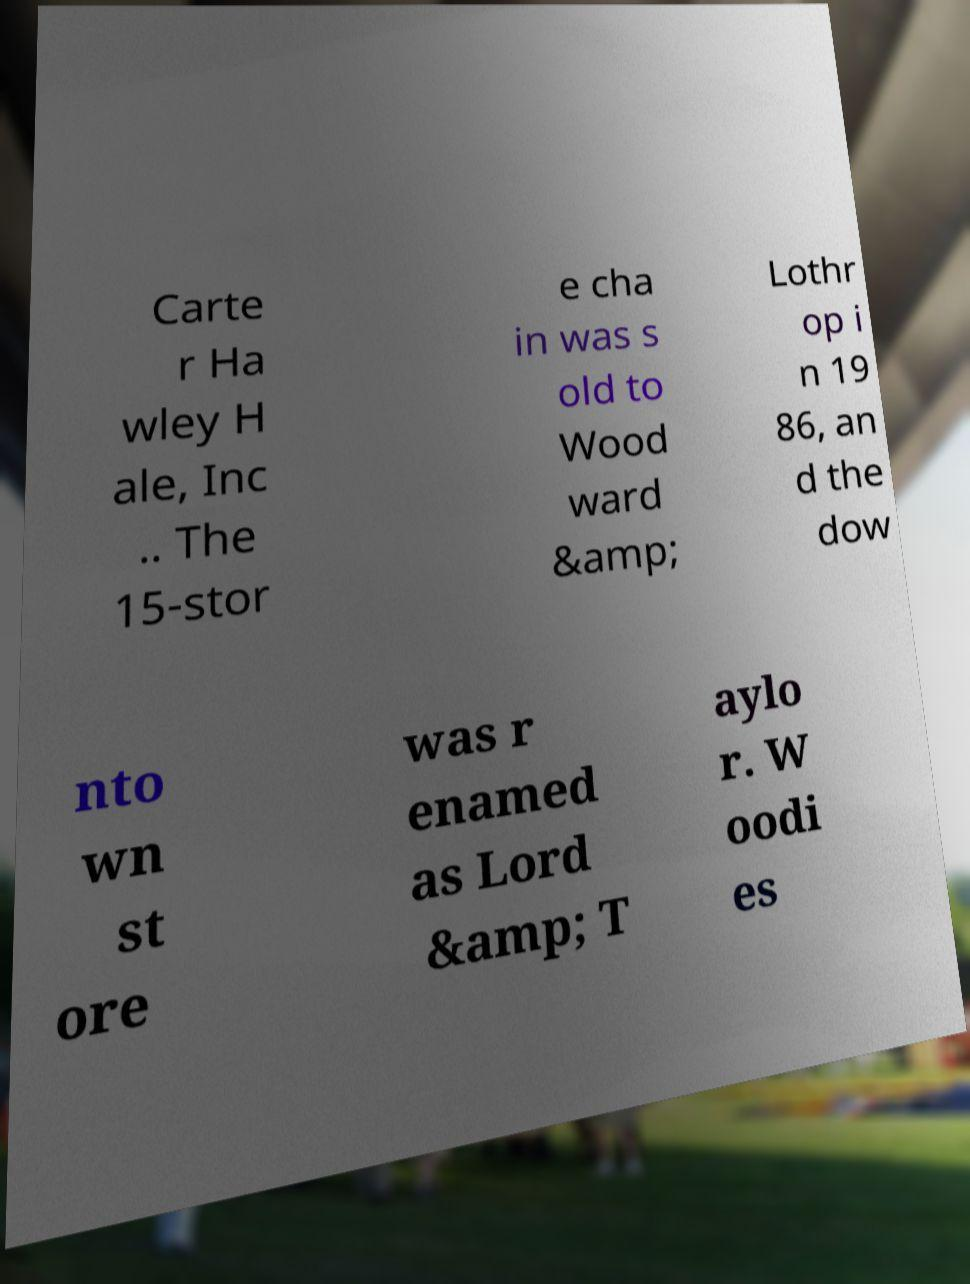For documentation purposes, I need the text within this image transcribed. Could you provide that? Carte r Ha wley H ale, Inc .. The 15-stor e cha in was s old to Wood ward &amp; Lothr op i n 19 86, an d the dow nto wn st ore was r enamed as Lord &amp; T aylo r. W oodi es 